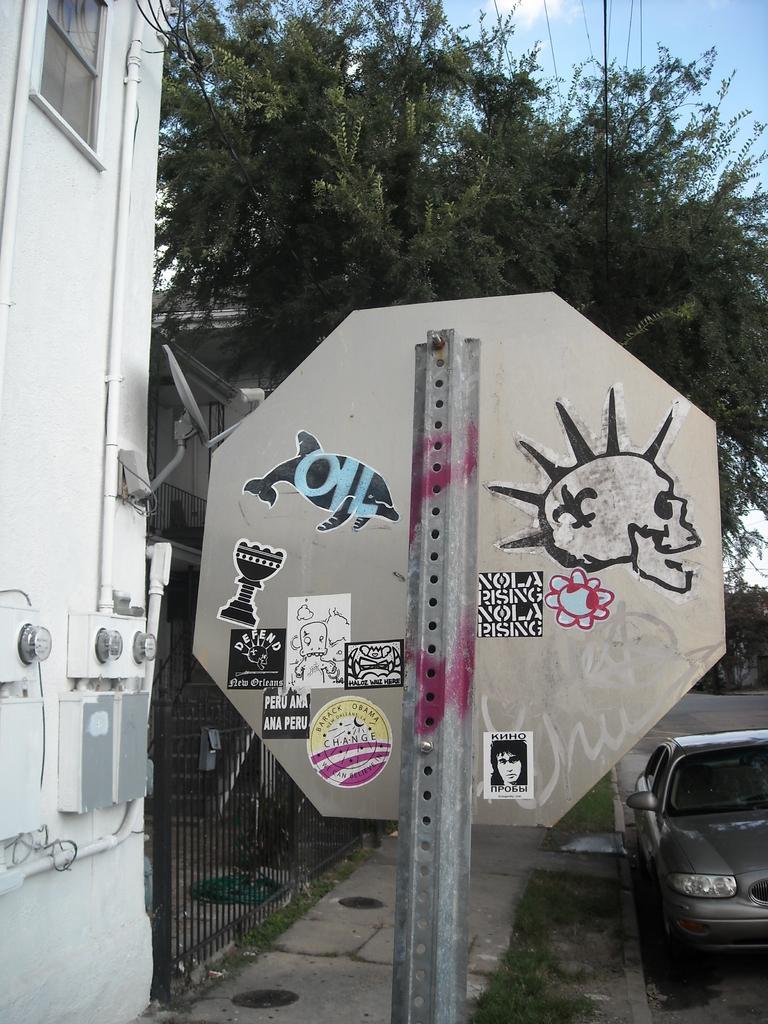Could you give a brief overview of what you see in this image? In this image we can see a sign board, Behind the sing board tree is there and car is there on road. Left side of the image one gate and building is present. 